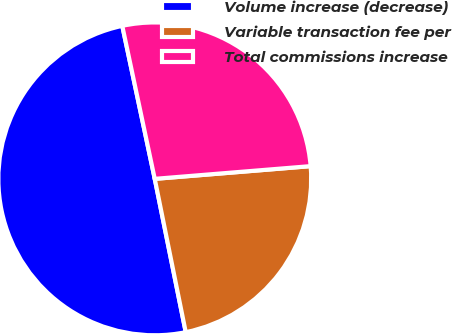<chart> <loc_0><loc_0><loc_500><loc_500><pie_chart><fcel>Volume increase (decrease)<fcel>Variable transaction fee per<fcel>Total commissions increase<nl><fcel>49.84%<fcel>23.12%<fcel>27.03%<nl></chart> 